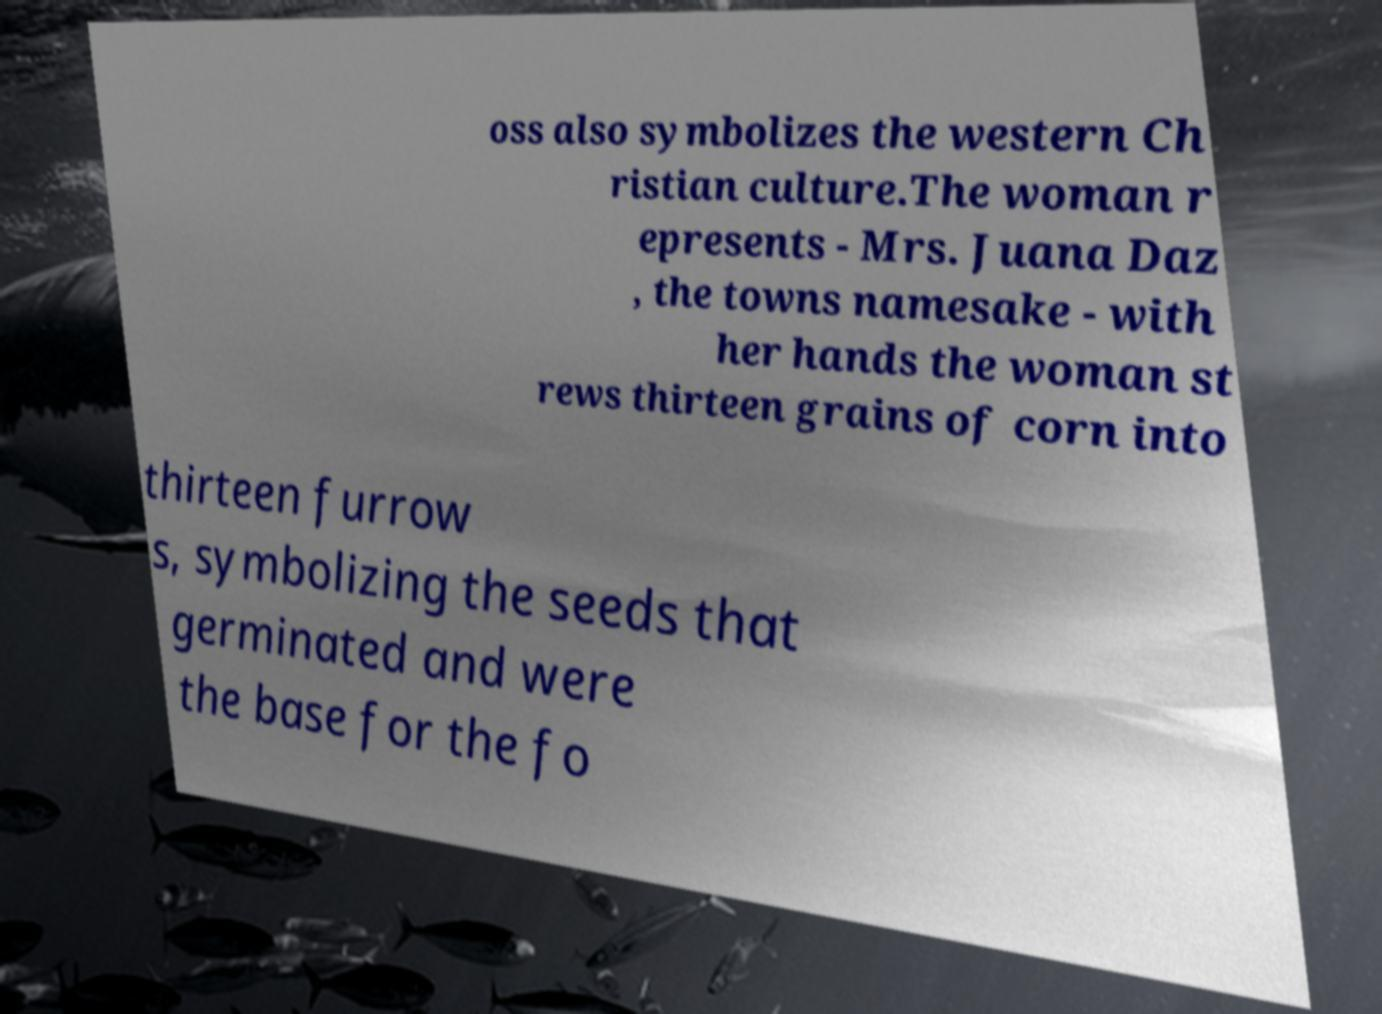What messages or text are displayed in this image? I need them in a readable, typed format. oss also symbolizes the western Ch ristian culture.The woman r epresents - Mrs. Juana Daz , the towns namesake - with her hands the woman st rews thirteen grains of corn into thirteen furrow s, symbolizing the seeds that germinated and were the base for the fo 